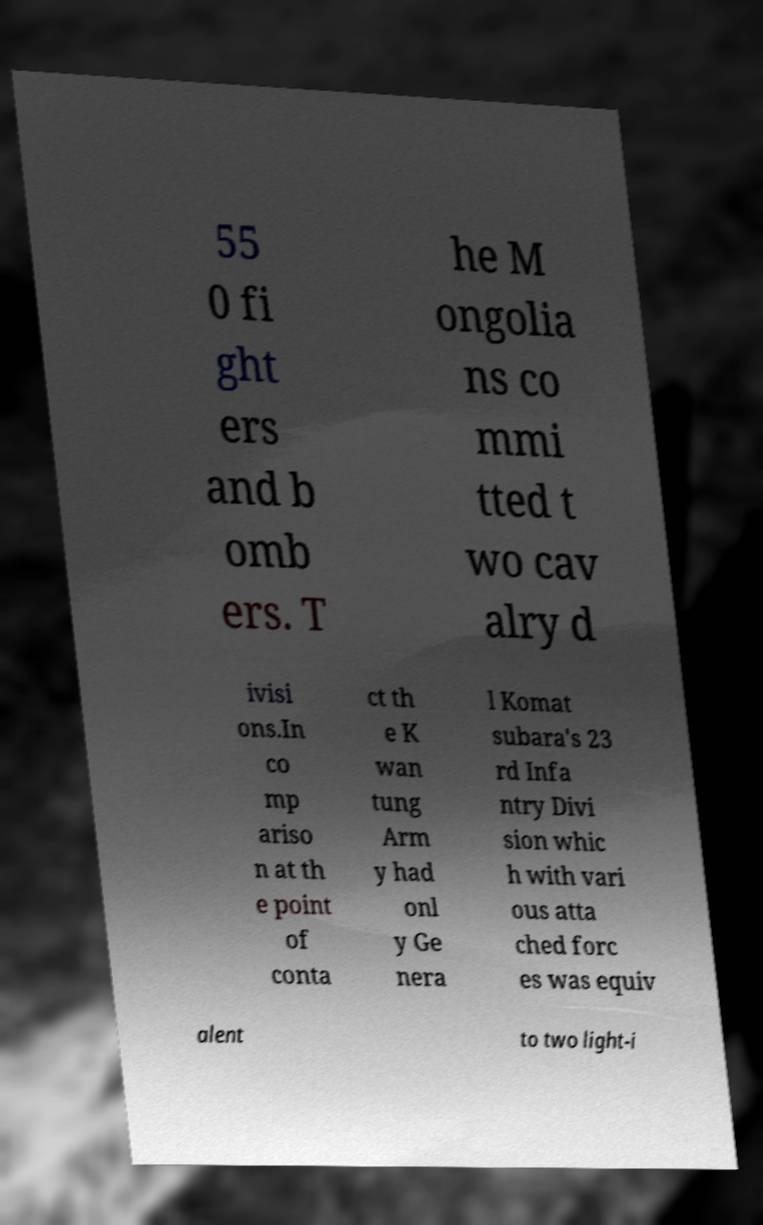Can you read and provide the text displayed in the image?This photo seems to have some interesting text. Can you extract and type it out for me? 55 0 fi ght ers and b omb ers. T he M ongolia ns co mmi tted t wo cav alry d ivisi ons.In co mp ariso n at th e point of conta ct th e K wan tung Arm y had onl y Ge nera l Komat subara's 23 rd Infa ntry Divi sion whic h with vari ous atta ched forc es was equiv alent to two light-i 